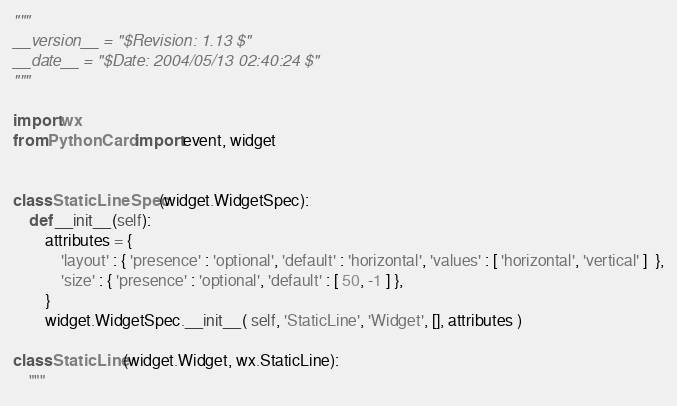<code> <loc_0><loc_0><loc_500><loc_500><_Python_>
"""
__version__ = "$Revision: 1.13 $"
__date__ = "$Date: 2004/05/13 02:40:24 $"
"""

import wx
from PythonCard import event, widget


class StaticLineSpec(widget.WidgetSpec):
    def __init__(self):
        attributes = {
            'layout' : { 'presence' : 'optional', 'default' : 'horizontal', 'values' : [ 'horizontal', 'vertical' ]  },
            'size' : { 'presence' : 'optional', 'default' : [ 50, -1 ] },
        }
        widget.WidgetSpec.__init__( self, 'StaticLine', 'Widget', [], attributes )

class StaticLine(widget.Widget, wx.StaticLine):
    """</code> 